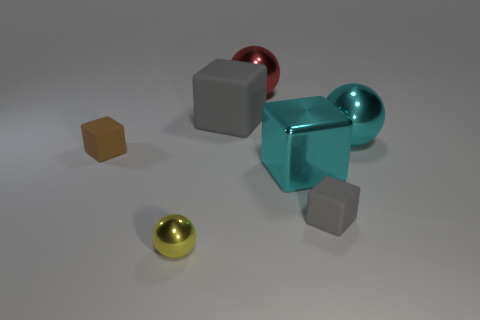Subtract all big rubber blocks. How many blocks are left? 3 Subtract all gray cubes. How many cubes are left? 2 Add 4 yellow metallic cylinders. How many yellow metallic cylinders exist? 4 Add 2 small yellow spheres. How many objects exist? 9 Subtract 0 purple cylinders. How many objects are left? 7 Subtract all blocks. How many objects are left? 3 Subtract 3 spheres. How many spheres are left? 0 Subtract all green spheres. Subtract all cyan blocks. How many spheres are left? 3 Subtract all yellow cubes. How many red spheres are left? 1 Subtract all cyan cubes. Subtract all large gray objects. How many objects are left? 5 